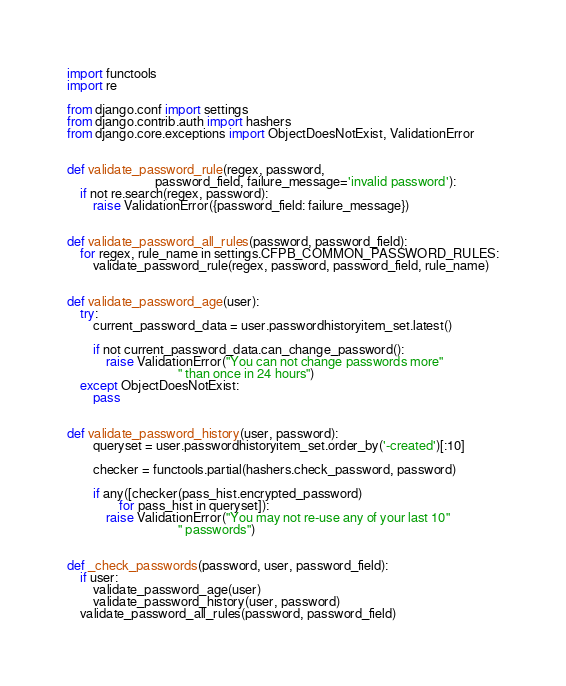Convert code to text. <code><loc_0><loc_0><loc_500><loc_500><_Python_>import functools
import re

from django.conf import settings
from django.contrib.auth import hashers
from django.core.exceptions import ObjectDoesNotExist, ValidationError


def validate_password_rule(regex, password,
                           password_field, failure_message='invalid password'):
    if not re.search(regex, password):
        raise ValidationError({password_field: failure_message})


def validate_password_all_rules(password, password_field):
    for regex, rule_name in settings.CFPB_COMMON_PASSWORD_RULES:
        validate_password_rule(regex, password, password_field, rule_name)


def validate_password_age(user):
    try:
        current_password_data = user.passwordhistoryitem_set.latest()

        if not current_password_data.can_change_password():
            raise ValidationError("You can not change passwords more"
                                  " than once in 24 hours")
    except ObjectDoesNotExist:
        pass


def validate_password_history(user, password):
        queryset = user.passwordhistoryitem_set.order_by('-created')[:10]

        checker = functools.partial(hashers.check_password, password)

        if any([checker(pass_hist.encrypted_password)
                for pass_hist in queryset]):
            raise ValidationError("You may not re-use any of your last 10"
                                  " passwords")


def _check_passwords(password, user, password_field):
    if user:
        validate_password_age(user)
        validate_password_history(user, password)
    validate_password_all_rules(password, password_field)
</code> 